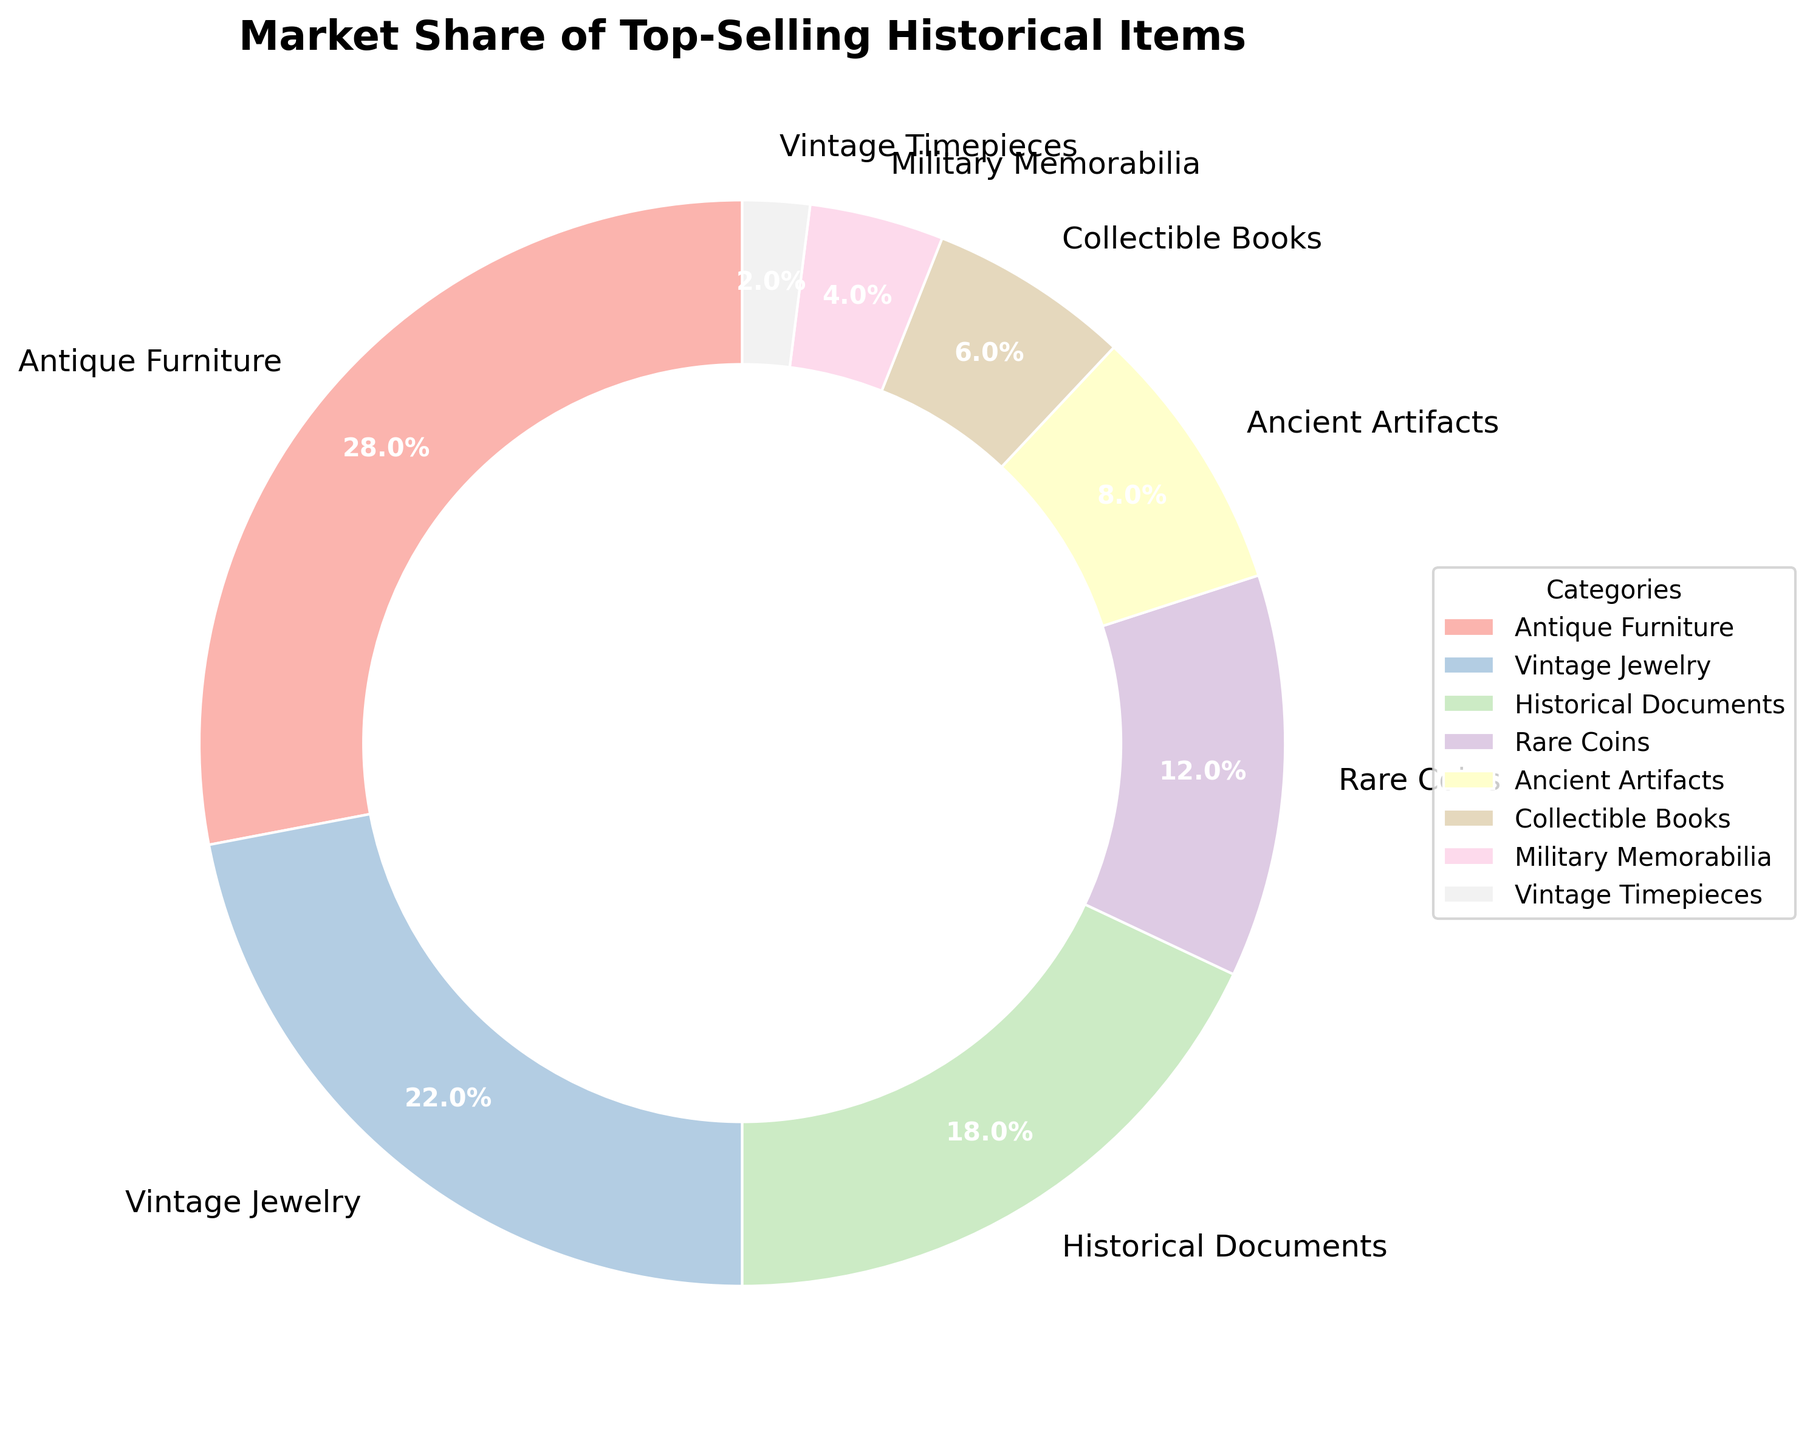What category holds the largest market share? The largest wedge in the pie chart represents the category with the largest market share; "Antique Furniture" is the largest segment.
Answer: Antique Furniture Which category has a market share greater than 20%? From the pie chart, the categories with market shares labeled above 20% are "Antique Furniture" and "Vintage Jewelry."
Answer: Antique Furniture and Vintage Jewelry What is the combined market share of Ancient Artifacts and Collectible Books? According to the chart, "Ancient Artifacts" has an 8% market share and "Collectible Books" has a 6% market share; adding these gives 8% + 6% = 14%.
Answer: 14% Which two categories together make up exactly 40% of the market share? The chart shows that "Vintage Jewelry" has 22% and "Historical Documents" has 18%; when combined, 22% + 18% = 40%.
Answer: Vintage Jewelry and Historical Documents Are there more categories with market shares greater than 10% or less than 10%? According to the chart, categories with more than 10% share are "Antique Furniture," "Vintage Jewelry," "Historical Documents," and "Rare Coins," making 4 categories. Categories with less than 10% are "Ancient Artifacts," "Collectible Books," "Military Memorabilia," and "Vintage Timepieces," also making 4 categories. Both quantities are equal.
Answer: Equal Which category has the smallest market share and what is it? The smallest wedge on the pie chart belongs to "Vintage Timepieces" with a market share of 2%.
Answer: Vintage Timepieces, 2% How much larger is the market share of Antique Furniture compared to Rare Coins? "Antique Furniture" has 28% while "Rare Coins" has 12%; the difference is 28% - 12% = 16%.
Answer: 16% What is the total market share covered by all categories except Antique Furniture? The total market share excluding "Antique Furniture" (28%) is 100% - 28% = 72%.
Answer: 72% Among the categories with market shares less than 10%, which has the highest market share? Among the categories under 10% - "Ancient Artifacts," "Collectible Books," "Military Memorabilia," and "Vintage Timepieces" - the highest market share is "Ancient Artifacts" at 8%.
Answer: Ancient Artifacts What is the average market share of all categories? The pie chart shows 8 categories with market shares: 28%, 22%, 18%, 12%, 8%, 6%, 4%, and 2%. Adding these: 28 + 22 + 18 + 12 + 8 + 6 + 4 + 2 = 100%. The average is 100% / 8 categories, which equals 12.5%.
Answer: 12.5% 